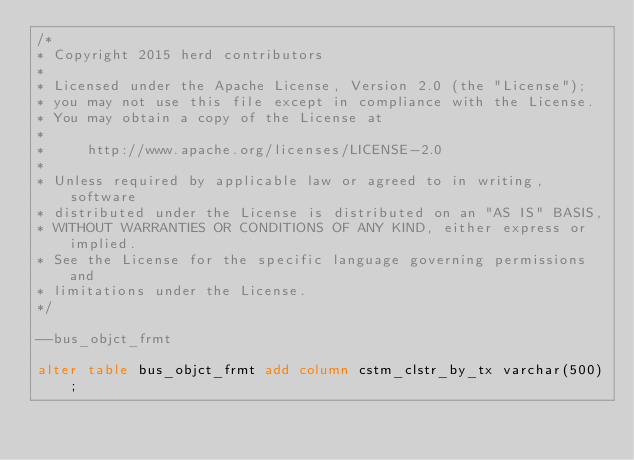Convert code to text. <code><loc_0><loc_0><loc_500><loc_500><_SQL_>/*
* Copyright 2015 herd contributors
*
* Licensed under the Apache License, Version 2.0 (the "License");
* you may not use this file except in compliance with the License.
* You may obtain a copy of the License at
*
*     http://www.apache.org/licenses/LICENSE-2.0
*
* Unless required by applicable law or agreed to in writing, software
* distributed under the License is distributed on an "AS IS" BASIS,
* WITHOUT WARRANTIES OR CONDITIONS OF ANY KIND, either express or implied.
* See the License for the specific language governing permissions and
* limitations under the License.
*/

--bus_objct_frmt

alter table bus_objct_frmt add column cstm_clstr_by_tx varchar(500);
</code> 